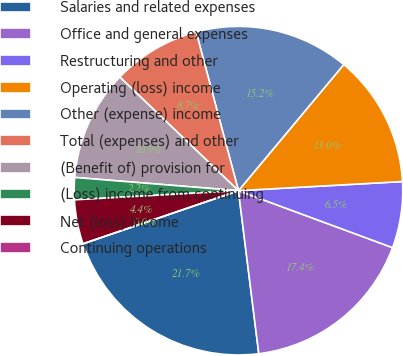<chart> <loc_0><loc_0><loc_500><loc_500><pie_chart><fcel>Salaries and related expenses<fcel>Office and general expenses<fcel>Restructuring and other<fcel>Operating (loss) income<fcel>Other (expense) income<fcel>Total (expenses) and other<fcel>(Benefit of) provision for<fcel>(Loss) income from continuing<fcel>Net (loss) income<fcel>Continuing operations<nl><fcel>21.74%<fcel>17.39%<fcel>6.52%<fcel>13.04%<fcel>15.22%<fcel>8.7%<fcel>10.87%<fcel>2.17%<fcel>4.35%<fcel>0.0%<nl></chart> 